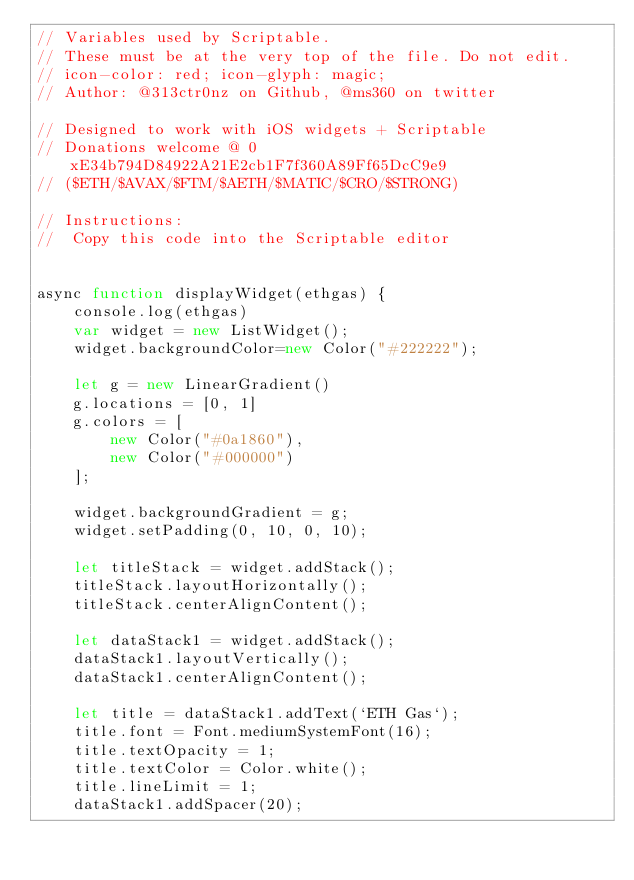Convert code to text. <code><loc_0><loc_0><loc_500><loc_500><_JavaScript_>// Variables used by Scriptable.
// These must be at the very top of the file. Do not edit.
// icon-color: red; icon-glyph: magic;
// Author: @313ctr0nz on Github, @ms360 on twitter

// Designed to work with iOS widgets + Scriptable
// Donations welcome @ 0xE34b794D84922A21E2cb1F7f360A89Ff65DcC9e9 
// ($ETH/$AVAX/$FTM/$AETH/$MATIC/$CRO/$STRONG)

// Instructions:
//  Copy this code into the Scriptable editor


async function displayWidget(ethgas) {
    console.log(ethgas)
    var widget = new ListWidget();
    widget.backgroundColor=new Color("#222222");

    let g = new LinearGradient()
    g.locations = [0, 1]
    g.colors = [
        new Color("#0a1860"),
        new Color("#000000")
    ];

    widget.backgroundGradient = g;
    widget.setPadding(0, 10, 0, 10);

    let titleStack = widget.addStack();
    titleStack.layoutHorizontally();
    titleStack.centerAlignContent();

    let dataStack1 = widget.addStack();
    dataStack1.layoutVertically();
    dataStack1.centerAlignContent();

    let title = dataStack1.addText(`ETH Gas`);
    title.font = Font.mediumSystemFont(16);
    title.textOpacity = 1;
    title.textColor = Color.white();
    title.lineLimit = 1;
    dataStack1.addSpacer(20);
</code> 